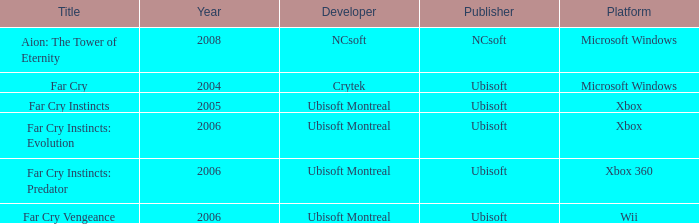Which publisher features far cry as the title? Ubisoft. 